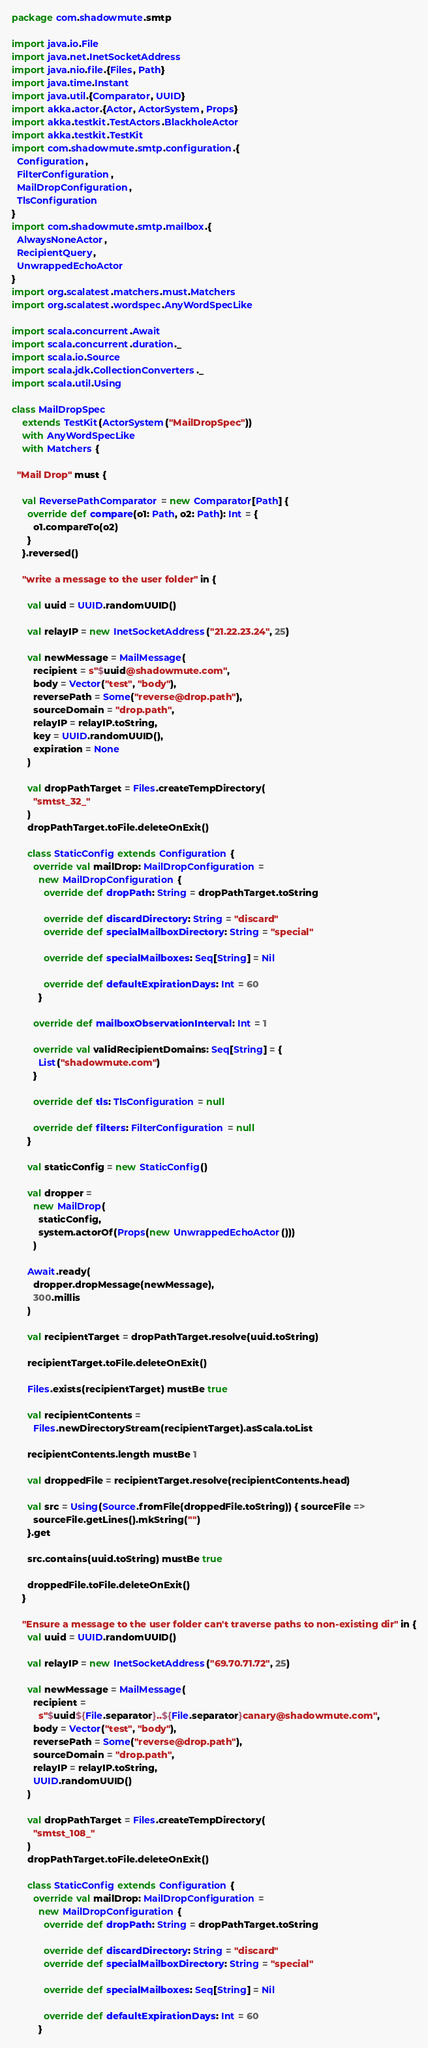Convert code to text. <code><loc_0><loc_0><loc_500><loc_500><_Scala_>package com.shadowmute.smtp

import java.io.File
import java.net.InetSocketAddress
import java.nio.file.{Files, Path}
import java.time.Instant
import java.util.{Comparator, UUID}
import akka.actor.{Actor, ActorSystem, Props}
import akka.testkit.TestActors.BlackholeActor
import akka.testkit.TestKit
import com.shadowmute.smtp.configuration.{
  Configuration,
  FilterConfiguration,
  MailDropConfiguration,
  TlsConfiguration
}
import com.shadowmute.smtp.mailbox.{
  AlwaysNoneActor,
  RecipientQuery,
  UnwrappedEchoActor
}
import org.scalatest.matchers.must.Matchers
import org.scalatest.wordspec.AnyWordSpecLike

import scala.concurrent.Await
import scala.concurrent.duration._
import scala.io.Source
import scala.jdk.CollectionConverters._
import scala.util.Using

class MailDropSpec
    extends TestKit(ActorSystem("MailDropSpec"))
    with AnyWordSpecLike
    with Matchers {

  "Mail Drop" must {

    val ReversePathComparator = new Comparator[Path] {
      override def compare(o1: Path, o2: Path): Int = {
        o1.compareTo(o2)
      }
    }.reversed()

    "write a message to the user folder" in {

      val uuid = UUID.randomUUID()

      val relayIP = new InetSocketAddress("21.22.23.24", 25)

      val newMessage = MailMessage(
        recipient = s"$uuid@shadowmute.com",
        body = Vector("test", "body"),
        reversePath = Some("reverse@drop.path"),
        sourceDomain = "drop.path",
        relayIP = relayIP.toString,
        key = UUID.randomUUID(),
        expiration = None
      )

      val dropPathTarget = Files.createTempDirectory(
        "smtst_32_"
      )
      dropPathTarget.toFile.deleteOnExit()

      class StaticConfig extends Configuration {
        override val mailDrop: MailDropConfiguration =
          new MailDropConfiguration {
            override def dropPath: String = dropPathTarget.toString

            override def discardDirectory: String = "discard"
            override def specialMailboxDirectory: String = "special"

            override def specialMailboxes: Seq[String] = Nil

            override def defaultExpirationDays: Int = 60
          }

        override def mailboxObservationInterval: Int = 1

        override val validRecipientDomains: Seq[String] = {
          List("shadowmute.com")
        }

        override def tls: TlsConfiguration = null

        override def filters: FilterConfiguration = null
      }

      val staticConfig = new StaticConfig()

      val dropper =
        new MailDrop(
          staticConfig,
          system.actorOf(Props(new UnwrappedEchoActor()))
        )

      Await.ready(
        dropper.dropMessage(newMessage),
        300.millis
      )

      val recipientTarget = dropPathTarget.resolve(uuid.toString)

      recipientTarget.toFile.deleteOnExit()

      Files.exists(recipientTarget) mustBe true

      val recipientContents =
        Files.newDirectoryStream(recipientTarget).asScala.toList

      recipientContents.length mustBe 1

      val droppedFile = recipientTarget.resolve(recipientContents.head)

      val src = Using(Source.fromFile(droppedFile.toString)) { sourceFile =>
        sourceFile.getLines().mkString("")
      }.get

      src.contains(uuid.toString) mustBe true

      droppedFile.toFile.deleteOnExit()
    }

    "Ensure a message to the user folder can't traverse paths to non-existing dir" in {
      val uuid = UUID.randomUUID()

      val relayIP = new InetSocketAddress("69.70.71.72", 25)

      val newMessage = MailMessage(
        recipient =
          s"$uuid${File.separator}..${File.separator}canary@shadowmute.com",
        body = Vector("test", "body"),
        reversePath = Some("reverse@drop.path"),
        sourceDomain = "drop.path",
        relayIP = relayIP.toString,
        UUID.randomUUID()
      )

      val dropPathTarget = Files.createTempDirectory(
        "smtst_108_"
      )
      dropPathTarget.toFile.deleteOnExit()

      class StaticConfig extends Configuration {
        override val mailDrop: MailDropConfiguration =
          new MailDropConfiguration {
            override def dropPath: String = dropPathTarget.toString

            override def discardDirectory: String = "discard"
            override def specialMailboxDirectory: String = "special"

            override def specialMailboxes: Seq[String] = Nil

            override def defaultExpirationDays: Int = 60
          }</code> 